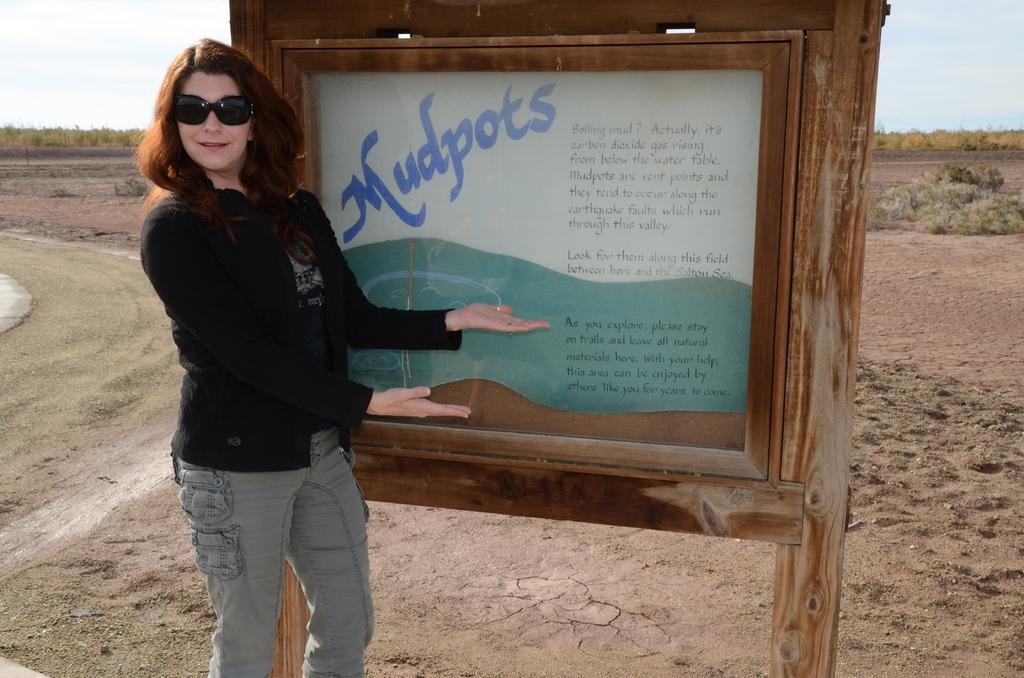Please provide a concise description of this image. In this image, we can see a lady wearing glasses and there is a board with some text. In the background, there are trees. At the bottom, there is ground. 